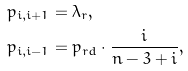<formula> <loc_0><loc_0><loc_500><loc_500>& p _ { i , i + 1 } = \lambda _ { r } , \\ & p _ { i , i - 1 } = p _ { r d } \cdot \frac { i } { n - 3 + i } ,</formula> 